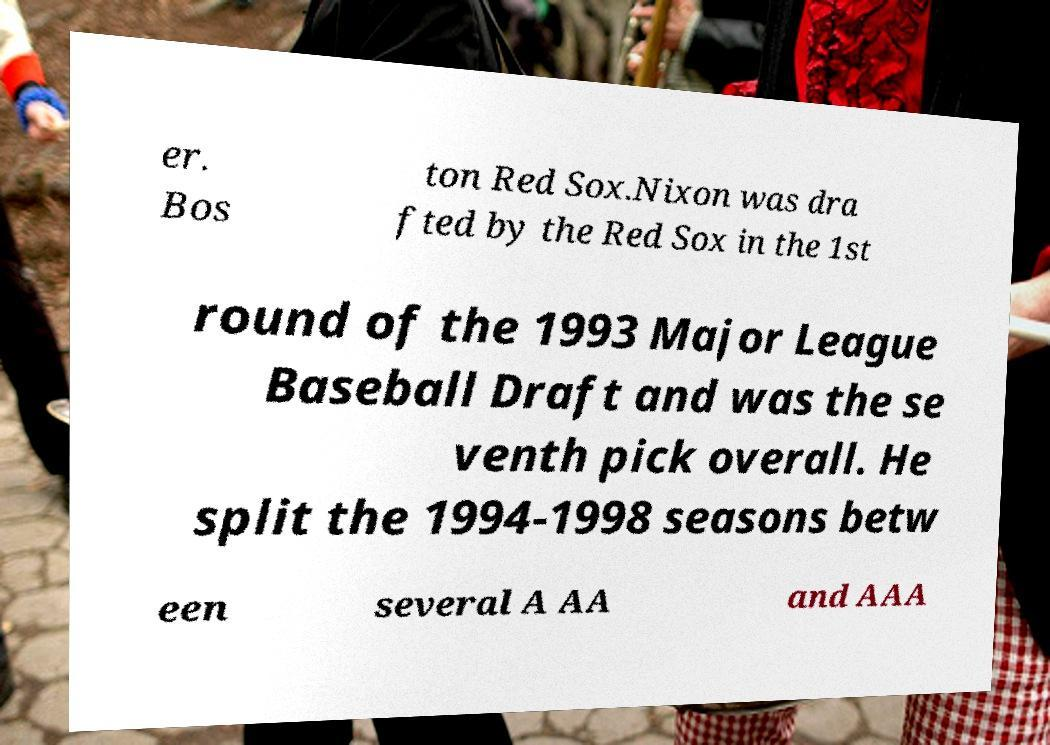For documentation purposes, I need the text within this image transcribed. Could you provide that? er. Bos ton Red Sox.Nixon was dra fted by the Red Sox in the 1st round of the 1993 Major League Baseball Draft and was the se venth pick overall. He split the 1994-1998 seasons betw een several A AA and AAA 